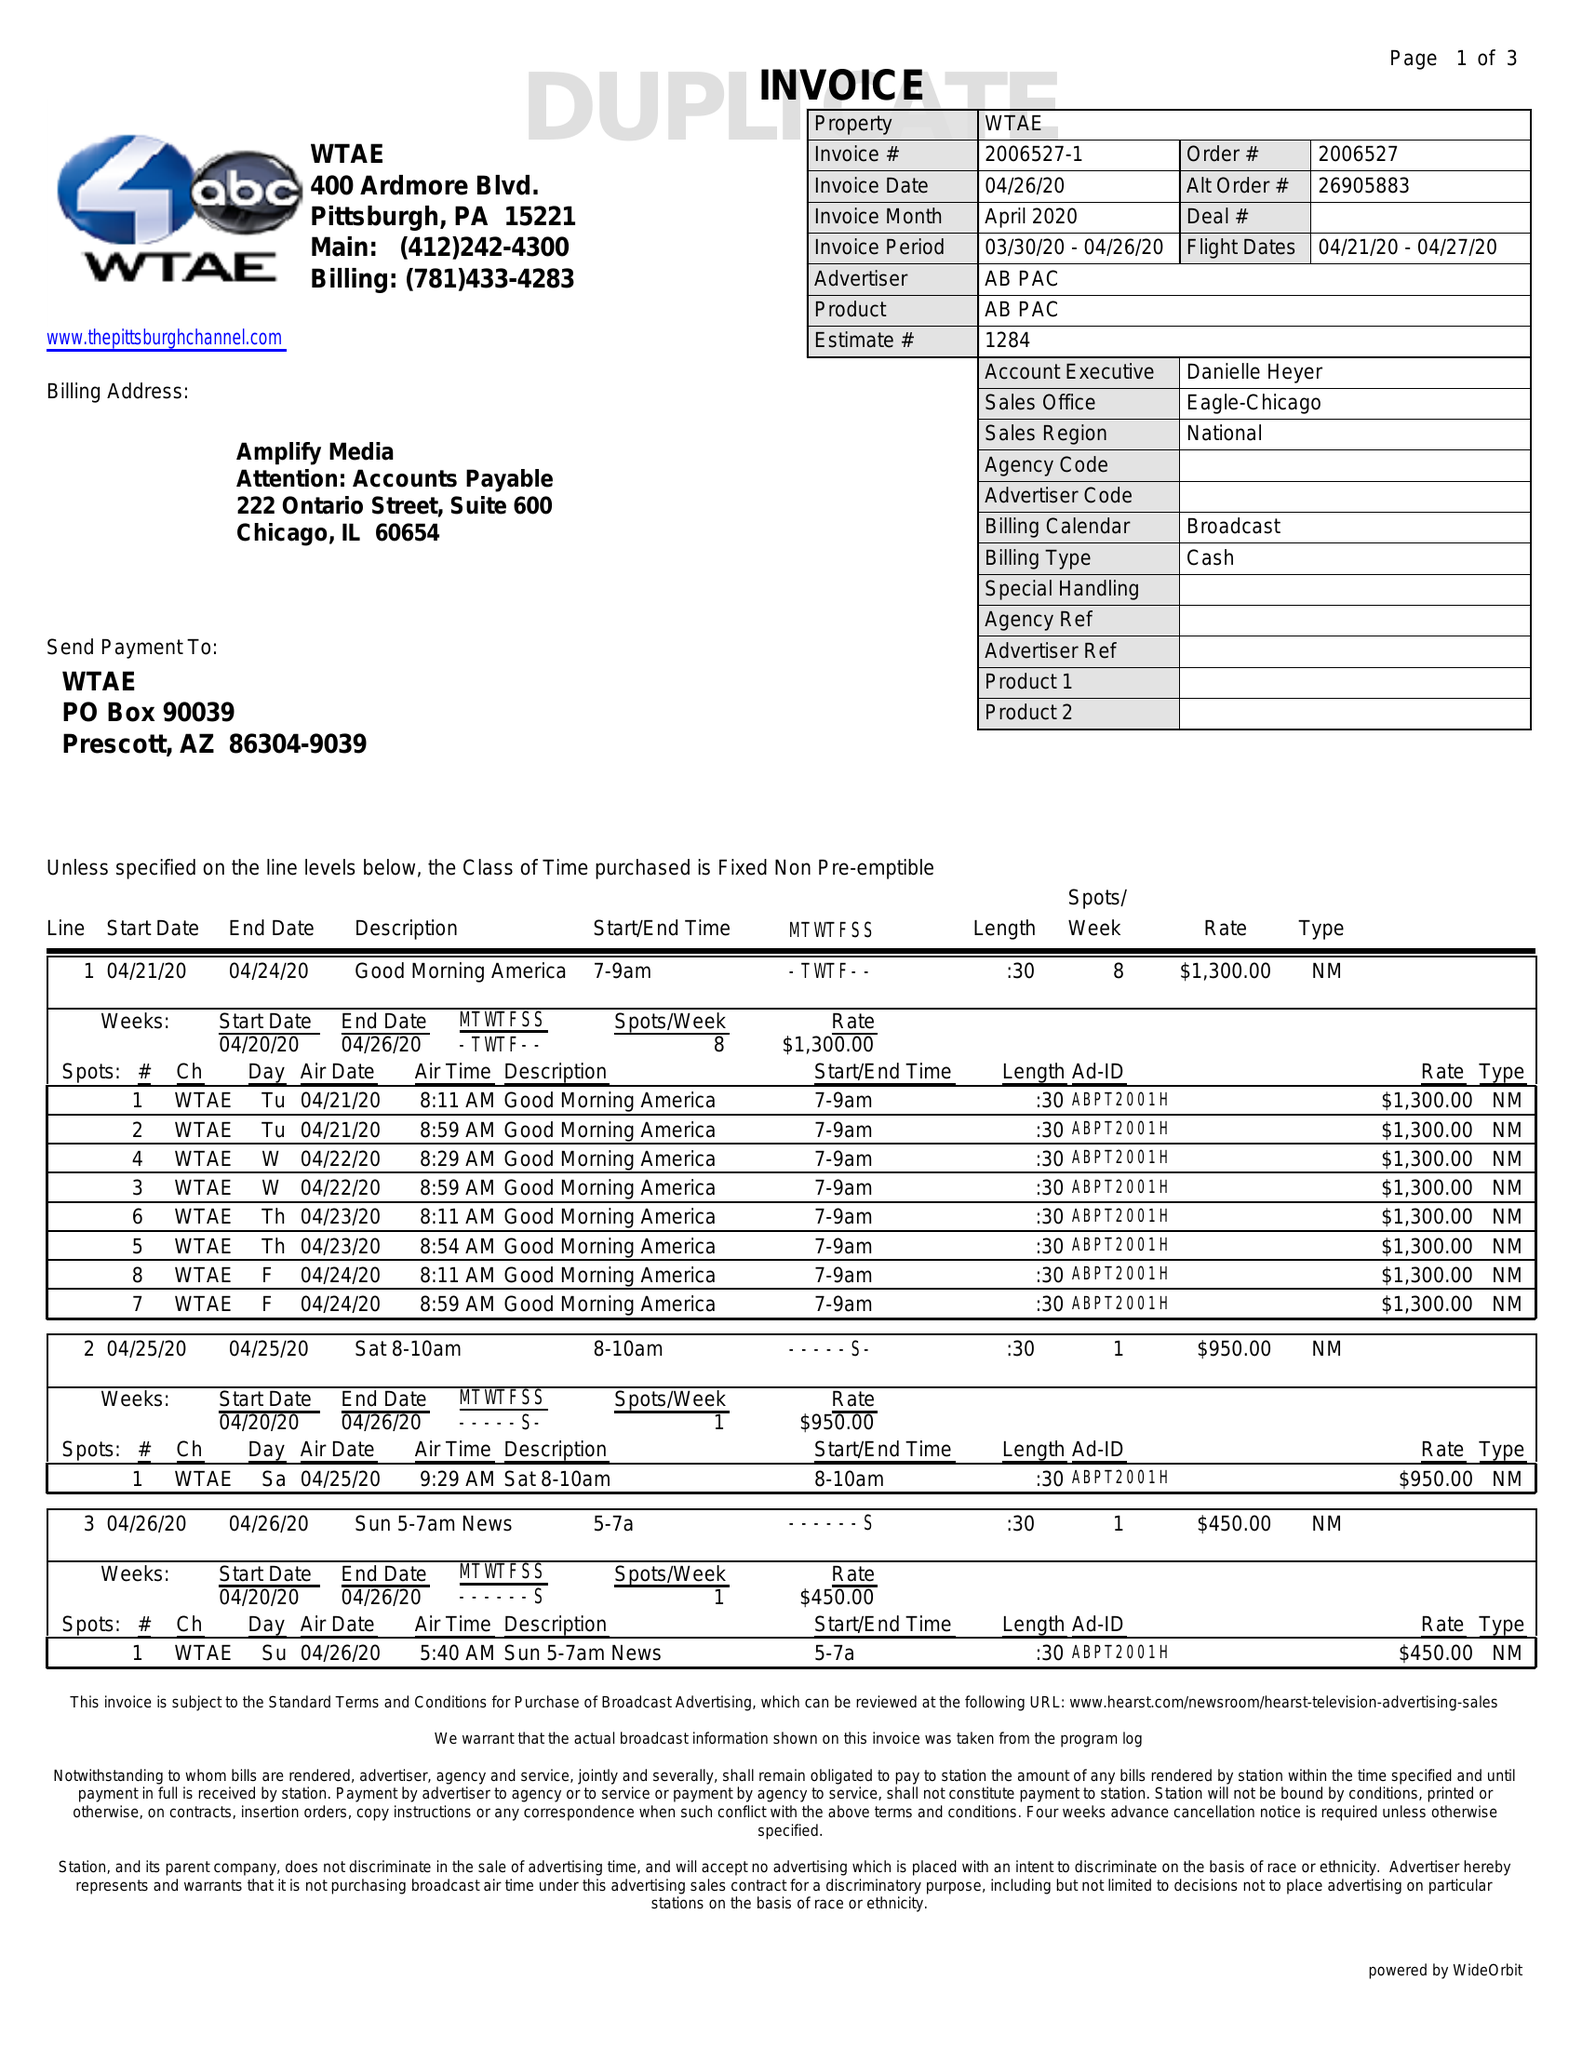What is the value for the flight_to?
Answer the question using a single word or phrase. 04/27/20 